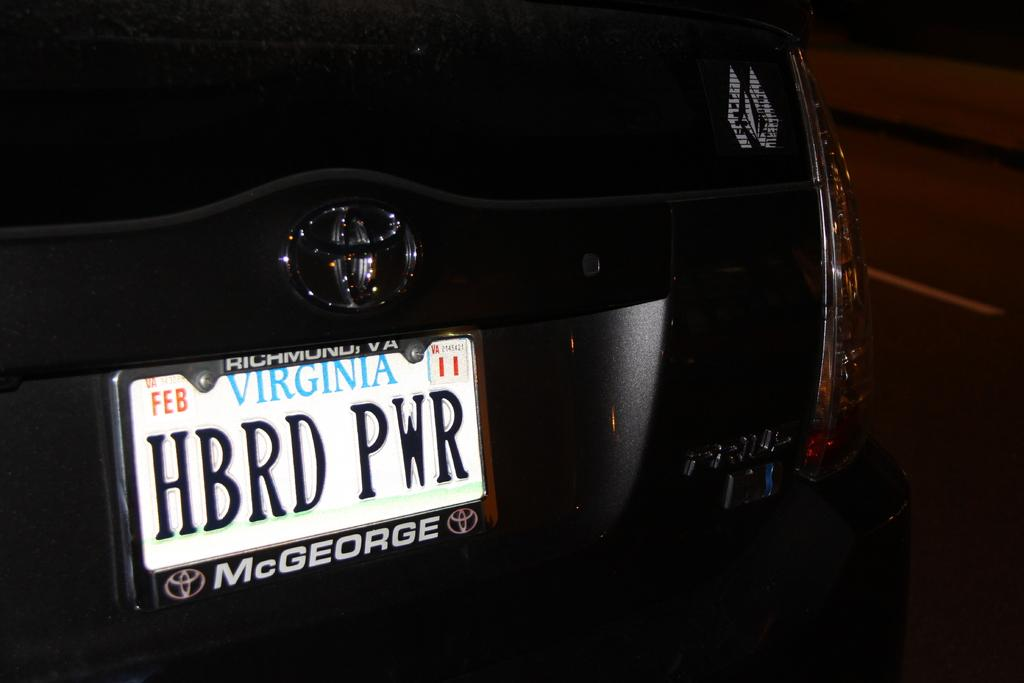Provide a one-sentence caption for the provided image. Black Toyota Vehicle with Virginia Number plate says short form of Hybrid Power. 